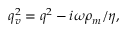<formula> <loc_0><loc_0><loc_500><loc_500>q _ { v } ^ { 2 } = q ^ { 2 } - i \omega \rho _ { m } / \eta ,</formula> 